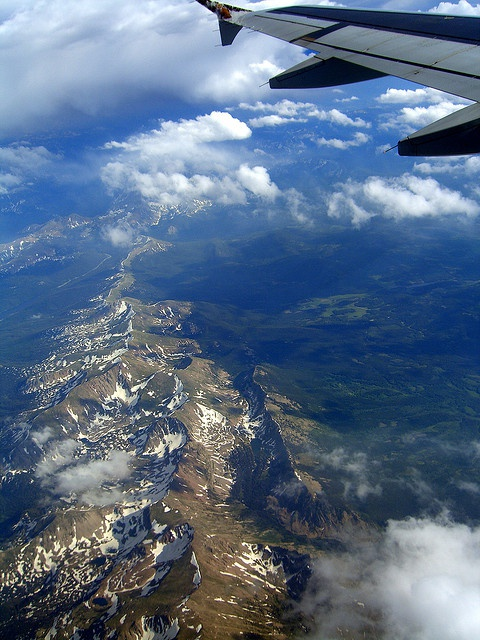Describe the objects in this image and their specific colors. I can see a airplane in lavender, black, gray, and navy tones in this image. 